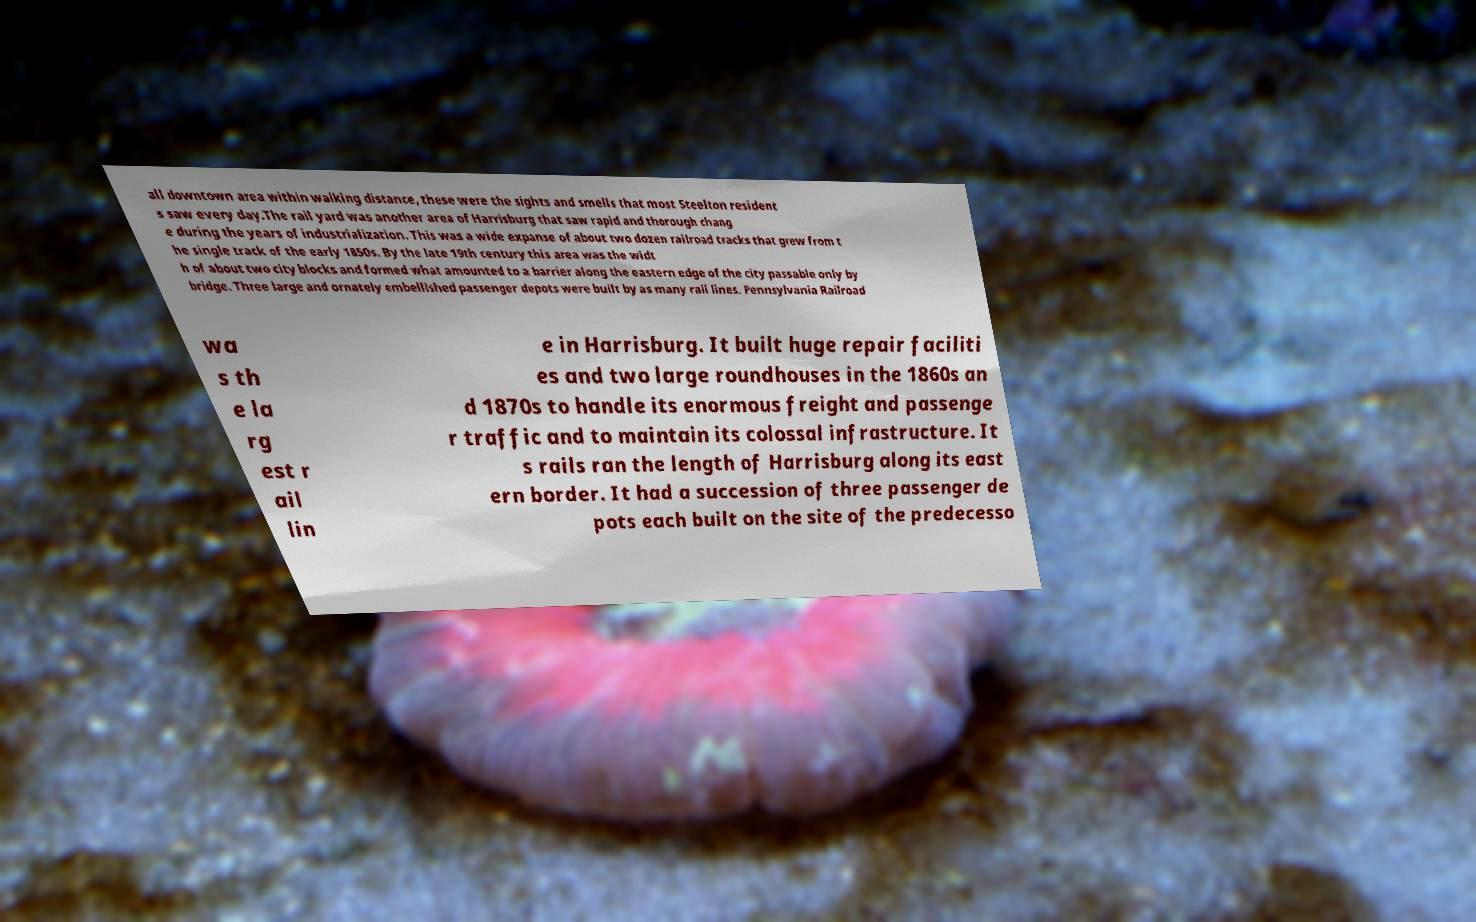I need the written content from this picture converted into text. Can you do that? all downtown area within walking distance, these were the sights and smells that most Steelton resident s saw every day.The rail yard was another area of Harrisburg that saw rapid and thorough chang e during the years of industrialization. This was a wide expanse of about two dozen railroad tracks that grew from t he single track of the early 1850s. By the late 19th century this area was the widt h of about two city blocks and formed what amounted to a barrier along the eastern edge of the city passable only by bridge. Three large and ornately embellished passenger depots were built by as many rail lines. Pennsylvania Railroad wa s th e la rg est r ail lin e in Harrisburg. It built huge repair faciliti es and two large roundhouses in the 1860s an d 1870s to handle its enormous freight and passenge r traffic and to maintain its colossal infrastructure. It s rails ran the length of Harrisburg along its east ern border. It had a succession of three passenger de pots each built on the site of the predecesso 